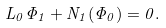<formula> <loc_0><loc_0><loc_500><loc_500>L _ { 0 } \Phi _ { 1 } + N _ { 1 } ( \Phi _ { 0 } ) = 0 .</formula> 